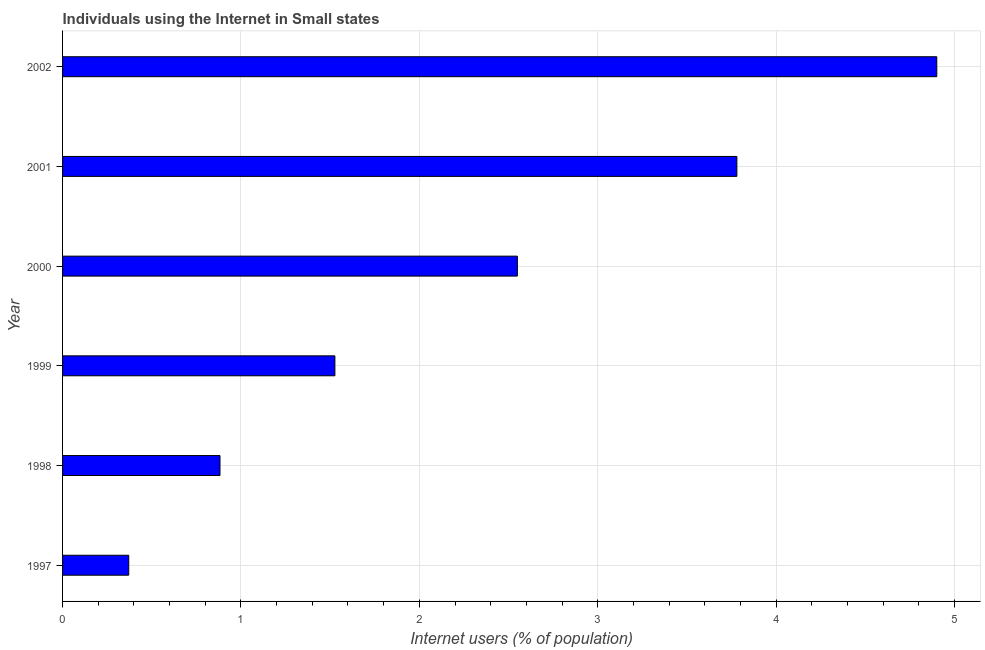Does the graph contain any zero values?
Provide a succinct answer. No. What is the title of the graph?
Your answer should be very brief. Individuals using the Internet in Small states. What is the label or title of the X-axis?
Provide a short and direct response. Internet users (% of population). What is the label or title of the Y-axis?
Your answer should be compact. Year. What is the number of internet users in 2002?
Offer a terse response. 4.9. Across all years, what is the maximum number of internet users?
Keep it short and to the point. 4.9. Across all years, what is the minimum number of internet users?
Your response must be concise. 0.37. In which year was the number of internet users maximum?
Your answer should be very brief. 2002. What is the sum of the number of internet users?
Offer a very short reply. 14.01. What is the difference between the number of internet users in 2000 and 2001?
Your answer should be very brief. -1.23. What is the average number of internet users per year?
Your response must be concise. 2.33. What is the median number of internet users?
Your response must be concise. 2.04. In how many years, is the number of internet users greater than 3.8 %?
Keep it short and to the point. 1. What is the ratio of the number of internet users in 1997 to that in 1998?
Offer a terse response. 0.42. Is the number of internet users in 1999 less than that in 2001?
Your answer should be very brief. Yes. What is the difference between the highest and the second highest number of internet users?
Make the answer very short. 1.12. What is the difference between the highest and the lowest number of internet users?
Offer a terse response. 4.53. In how many years, is the number of internet users greater than the average number of internet users taken over all years?
Offer a terse response. 3. How many bars are there?
Ensure brevity in your answer.  6. Are the values on the major ticks of X-axis written in scientific E-notation?
Offer a very short reply. No. What is the Internet users (% of population) of 1997?
Make the answer very short. 0.37. What is the Internet users (% of population) of 1998?
Keep it short and to the point. 0.88. What is the Internet users (% of population) in 1999?
Offer a terse response. 1.53. What is the Internet users (% of population) in 2000?
Provide a succinct answer. 2.55. What is the Internet users (% of population) of 2001?
Keep it short and to the point. 3.78. What is the Internet users (% of population) in 2002?
Your response must be concise. 4.9. What is the difference between the Internet users (% of population) in 1997 and 1998?
Provide a short and direct response. -0.51. What is the difference between the Internet users (% of population) in 1997 and 1999?
Provide a succinct answer. -1.16. What is the difference between the Internet users (% of population) in 1997 and 2000?
Provide a short and direct response. -2.18. What is the difference between the Internet users (% of population) in 1997 and 2001?
Keep it short and to the point. -3.41. What is the difference between the Internet users (% of population) in 1997 and 2002?
Give a very brief answer. -4.53. What is the difference between the Internet users (% of population) in 1998 and 1999?
Offer a terse response. -0.64. What is the difference between the Internet users (% of population) in 1998 and 2000?
Your answer should be compact. -1.67. What is the difference between the Internet users (% of population) in 1998 and 2001?
Provide a succinct answer. -2.9. What is the difference between the Internet users (% of population) in 1998 and 2002?
Give a very brief answer. -4.02. What is the difference between the Internet users (% of population) in 1999 and 2000?
Make the answer very short. -1.02. What is the difference between the Internet users (% of population) in 1999 and 2001?
Keep it short and to the point. -2.25. What is the difference between the Internet users (% of population) in 1999 and 2002?
Make the answer very short. -3.37. What is the difference between the Internet users (% of population) in 2000 and 2001?
Provide a short and direct response. -1.23. What is the difference between the Internet users (% of population) in 2000 and 2002?
Your answer should be very brief. -2.35. What is the difference between the Internet users (% of population) in 2001 and 2002?
Your answer should be very brief. -1.12. What is the ratio of the Internet users (% of population) in 1997 to that in 1998?
Offer a very short reply. 0.42. What is the ratio of the Internet users (% of population) in 1997 to that in 1999?
Provide a short and direct response. 0.24. What is the ratio of the Internet users (% of population) in 1997 to that in 2000?
Provide a short and direct response. 0.14. What is the ratio of the Internet users (% of population) in 1997 to that in 2001?
Your answer should be very brief. 0.1. What is the ratio of the Internet users (% of population) in 1997 to that in 2002?
Provide a short and direct response. 0.08. What is the ratio of the Internet users (% of population) in 1998 to that in 1999?
Offer a terse response. 0.58. What is the ratio of the Internet users (% of population) in 1998 to that in 2000?
Your answer should be very brief. 0.35. What is the ratio of the Internet users (% of population) in 1998 to that in 2001?
Offer a very short reply. 0.23. What is the ratio of the Internet users (% of population) in 1998 to that in 2002?
Provide a succinct answer. 0.18. What is the ratio of the Internet users (% of population) in 1999 to that in 2000?
Give a very brief answer. 0.6. What is the ratio of the Internet users (% of population) in 1999 to that in 2001?
Make the answer very short. 0.4. What is the ratio of the Internet users (% of population) in 1999 to that in 2002?
Your answer should be compact. 0.31. What is the ratio of the Internet users (% of population) in 2000 to that in 2001?
Offer a terse response. 0.67. What is the ratio of the Internet users (% of population) in 2000 to that in 2002?
Your response must be concise. 0.52. What is the ratio of the Internet users (% of population) in 2001 to that in 2002?
Provide a succinct answer. 0.77. 